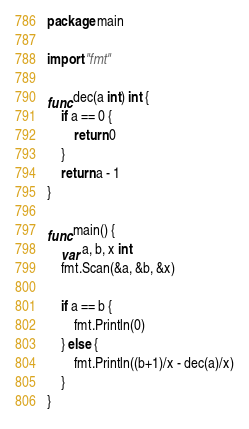Convert code to text. <code><loc_0><loc_0><loc_500><loc_500><_Go_>package main

import "fmt"

func dec(a int) int {
	if a == 0 {
		return 0
	}
	return a - 1
}

func main() {
	var a, b, x int
	fmt.Scan(&a, &b, &x)

	if a == b {
		fmt.Println(0)
	} else {
		fmt.Println((b+1)/x - dec(a)/x)
	}
}
</code> 